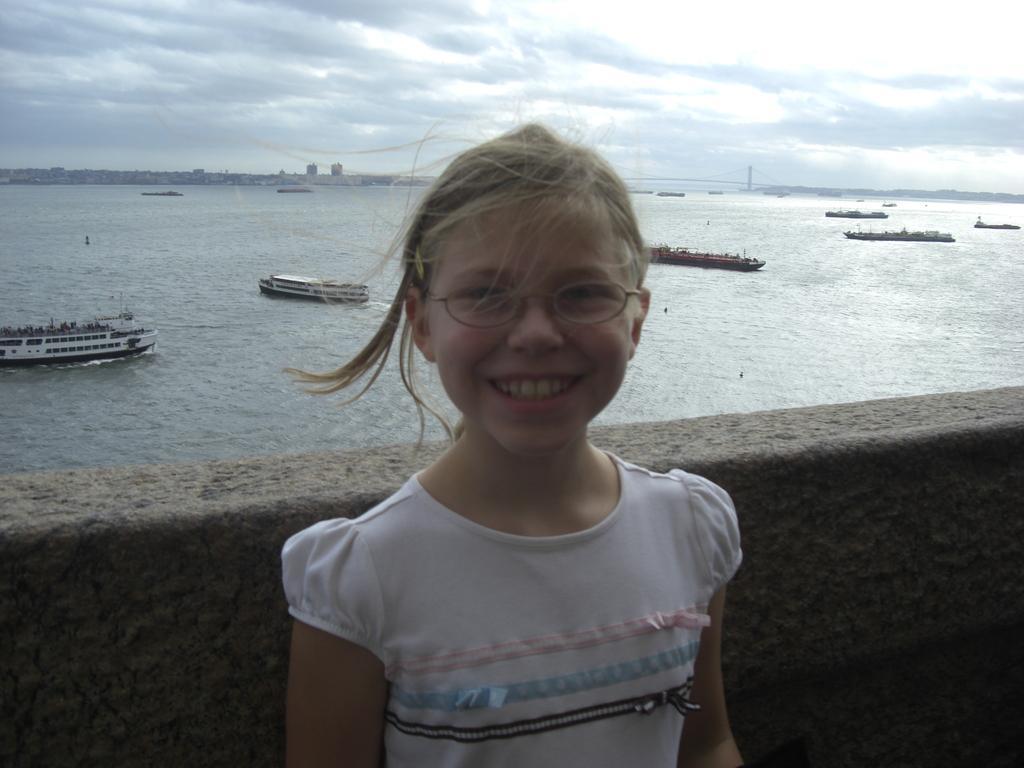Describe this image in one or two sentences. In the image there is a girl standing in front of wall smiling and behind her there is ocean with ships in it and above its sky with clouds. 